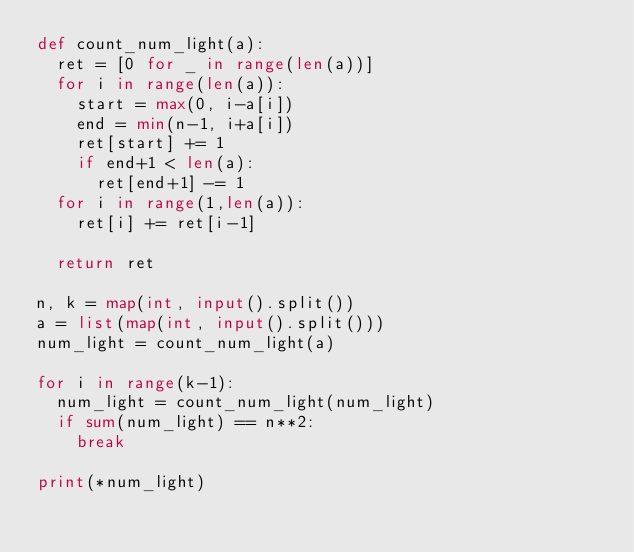<code> <loc_0><loc_0><loc_500><loc_500><_Python_>def count_num_light(a):
  ret = [0 for _ in range(len(a))]
  for i in range(len(a)):
    start = max(0, i-a[i])
    end = min(n-1, i+a[i])
    ret[start] += 1
    if end+1 < len(a):
      ret[end+1] -= 1
  for i in range(1,len(a)):
    ret[i] += ret[i-1]
  
  return ret
                  
n, k = map(int, input().split())
a = list(map(int, input().split()))
num_light = count_num_light(a)
 
for i in range(k-1):
  num_light = count_num_light(num_light)
  if sum(num_light) == n**2:
    break
    
print(*num_light)
</code> 